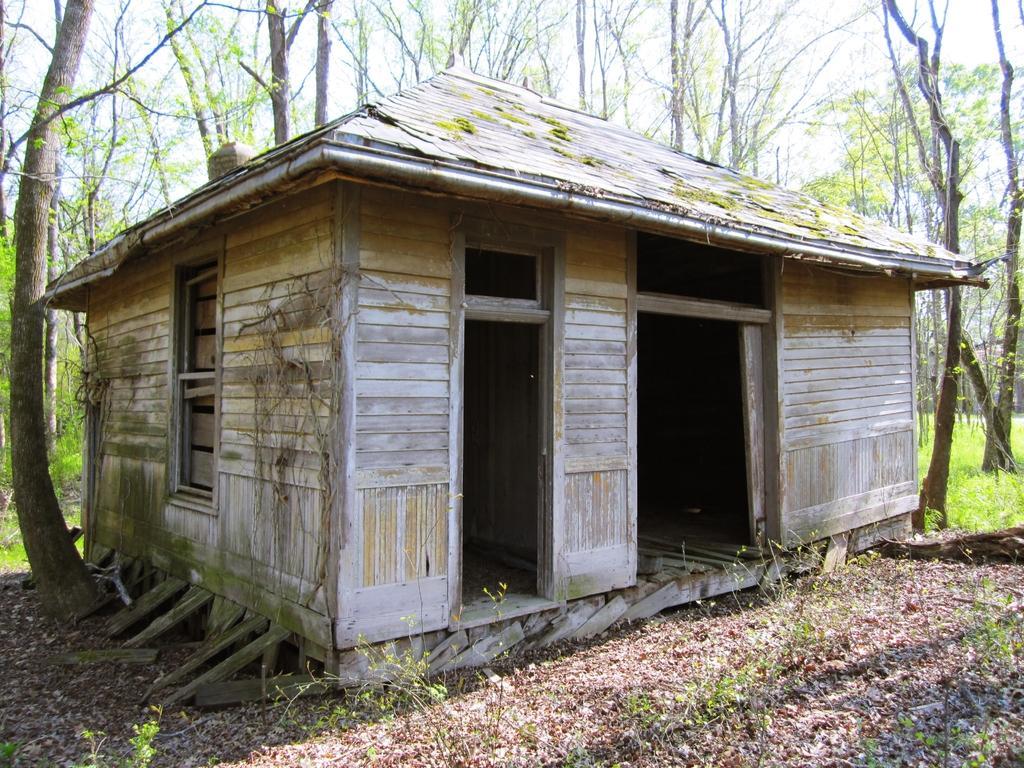Could you give a brief overview of what you see in this image? In this image in the center there is a house. In the background there are trees and there's grass on the ground. 